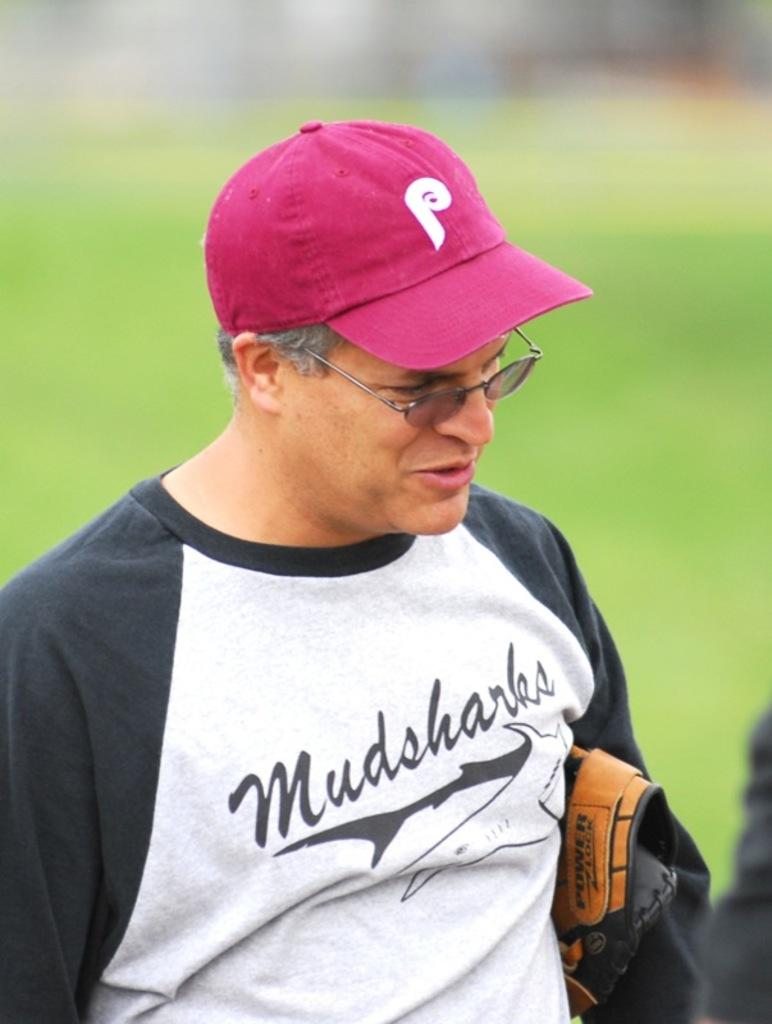<image>
Give a short and clear explanation of the subsequent image. A man wearing a purple cap and glasses has the word Mudsharks on his top as he tucks his catching glove under his arm. 